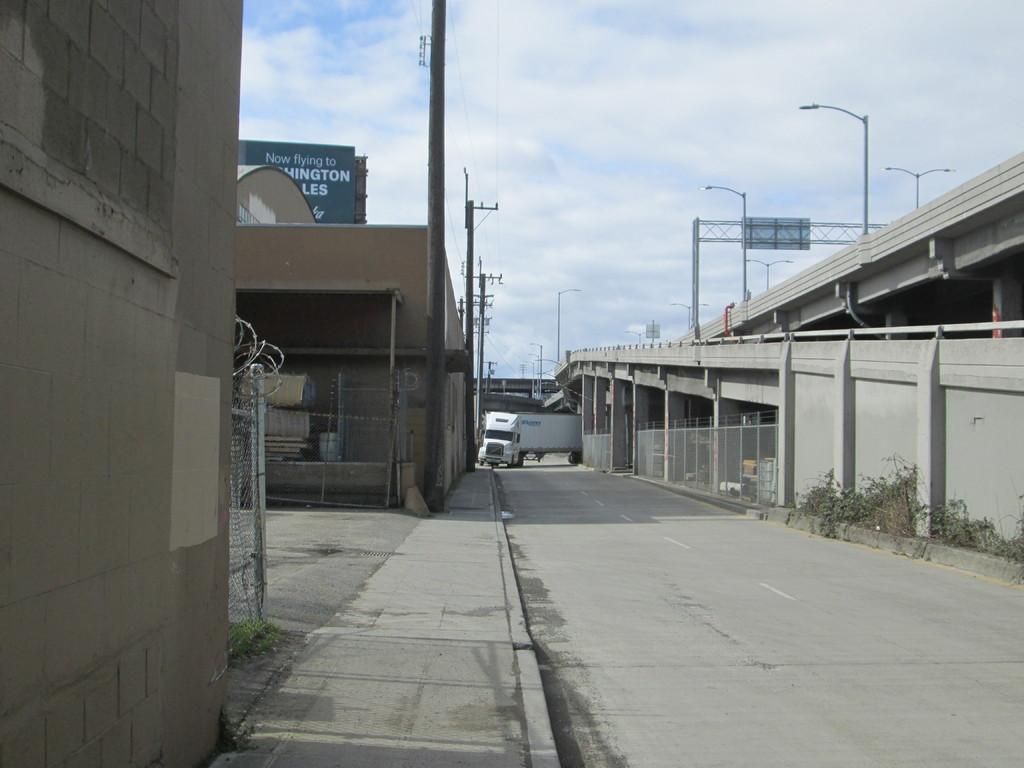What is the main subject in the center of the image? There is a truck in the center of the image. Where is the truck located? The truck is on the road. What can be seen to the right side of the image? There is a bridge to the right side of the image. What structures are present in the image? There are electric poles and fencing in the image. How many pets are sitting on the table in the image? There is no table or pets present in the image. 